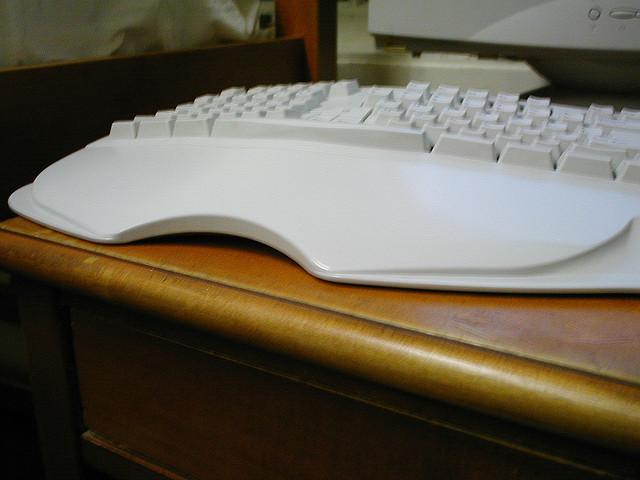Is this an office or home office?
Short answer required. Home office. What color is the keyboard?
Quick response, please. White. What is favori?
Keep it brief. Keyboard. Are there any electronics in this photo?
Short answer required. Yes. 